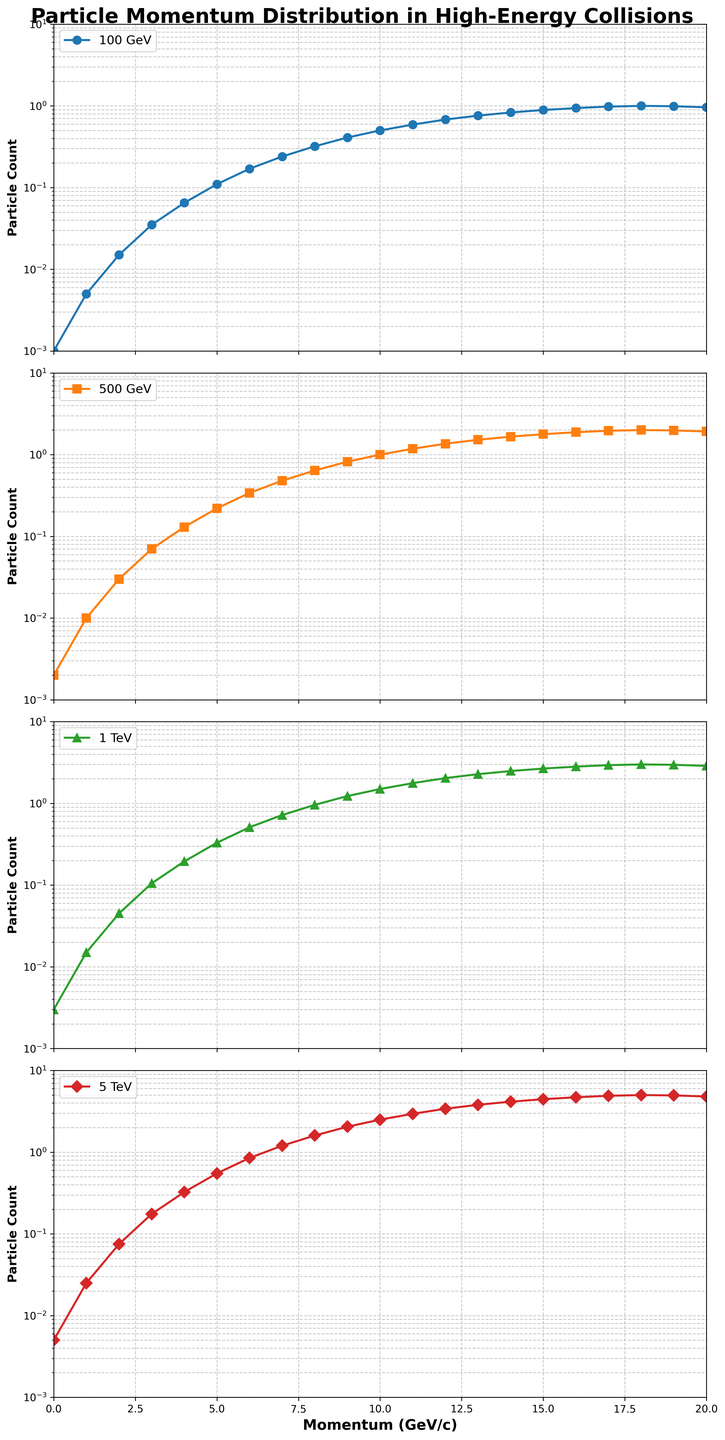What is the particle count at 10 GeV/c for the collision energy of 1 TeV? Refer to the second subplot from the top which represents the 1 TeV collision energy. Look for 10 on the x-axis (momentum) and read the corresponding y-axis value which represents the particle count.
Answer: 1.5 How does the particle count at 5 GeV/c compare between 100 GeV and 5 TeV collision energies? Look at the first and fourth subplots and observe the particle count at 5 GeV/c. For 100 GeV, it is 0.11, and for 5 TeV, it is 0.55. Comparing these two values, 0.55 is greater than 0.11.
Answer: The particle count at 5 TeV is greater What is the difference in particle count at 3 GeV/c between collision energies of 500 GeV and 1 TeV? Check the second and third subplots for the particle count at 3 GeV/c. For 500 GeV, it is 0.07, and for 1 TeV, it is 0.105. Subtract 0.07 from 0.105 to get the difference.
Answer: 0.035 At what momentum value do all four collision energies have approximately equal particle counts? Scan through the plots and find a momentum (x-axis) where the y-values (particle count) of all four subplots are roughly the same. Mostly, around momentum value 18 GeV/c, the counts converge to around 1.0.
Answer: Around 18 GeV/c Does the particle count increase or decrease at higher momentum for the 5 TeV collision energy? Refer to the fourth subplot. Observe how the line moves as the x-axis (momentum) increases. The particle count increases initially and then decreases after peaking around 18 GeV/c.
Answer: Increases initially, then decreases Which collision energy has the steepest increase in particle count as momentum goes from 6 to 10 GeV/c? Examine the slopes of the lines between 6 and 10 GeV/c across all subplots. The fourth subplot (5 TeV collision energy) shows the steepest increase in particle count within this range.
Answer: 5 TeV At a momentum of 12 GeV/c, which collision energy has the maximum particle count, and what is its value? Check the y-values corresponding to 12 GeV/c across all subplots. The fourth subplot (5 TeV collision energy) has the highest particle count which is 3.4.
Answer: 5 TeV, 3.4 What trend do you observe in the particle count distribution for increasing collision energy? Examine the subplots sequentially from top to bottom. Notice how the particle counts generally increase as collision energy increases from 100 GeV to 5 TeV.
Answer: Counts increase with higher collision energies 